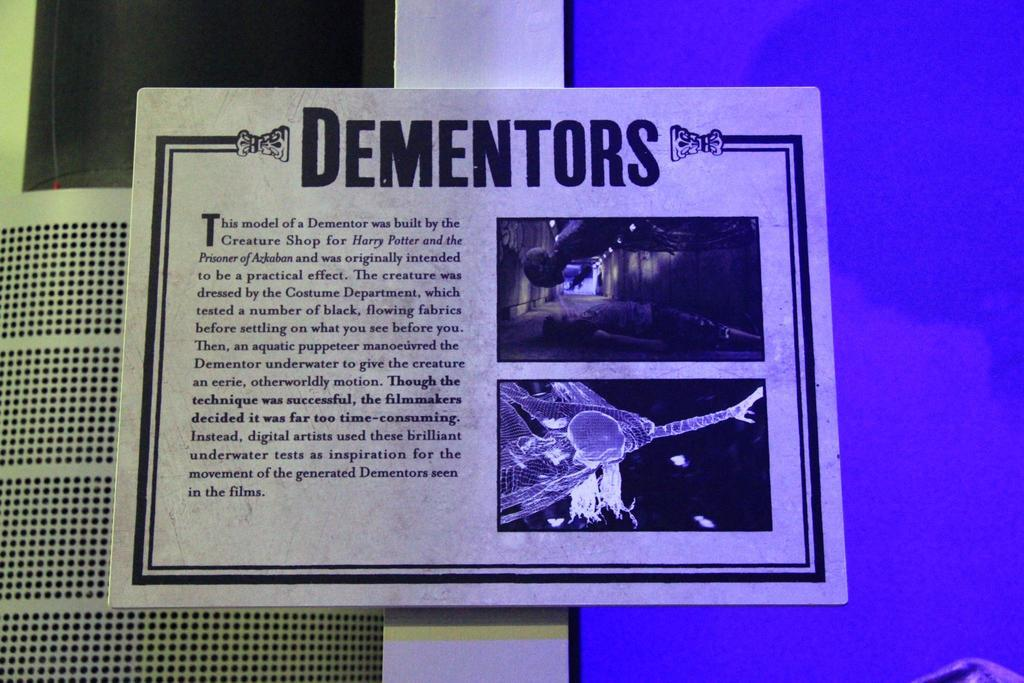What is the main object in the image? There is a white color board in the image. What is on the color board? Something is written on the board, and there are pictures on it. What is the background color in the image? The background color is blue. Can you tell me how many toads are jumping on the color board in the image? There are no toads present in the image; the board contains written content and pictures. 